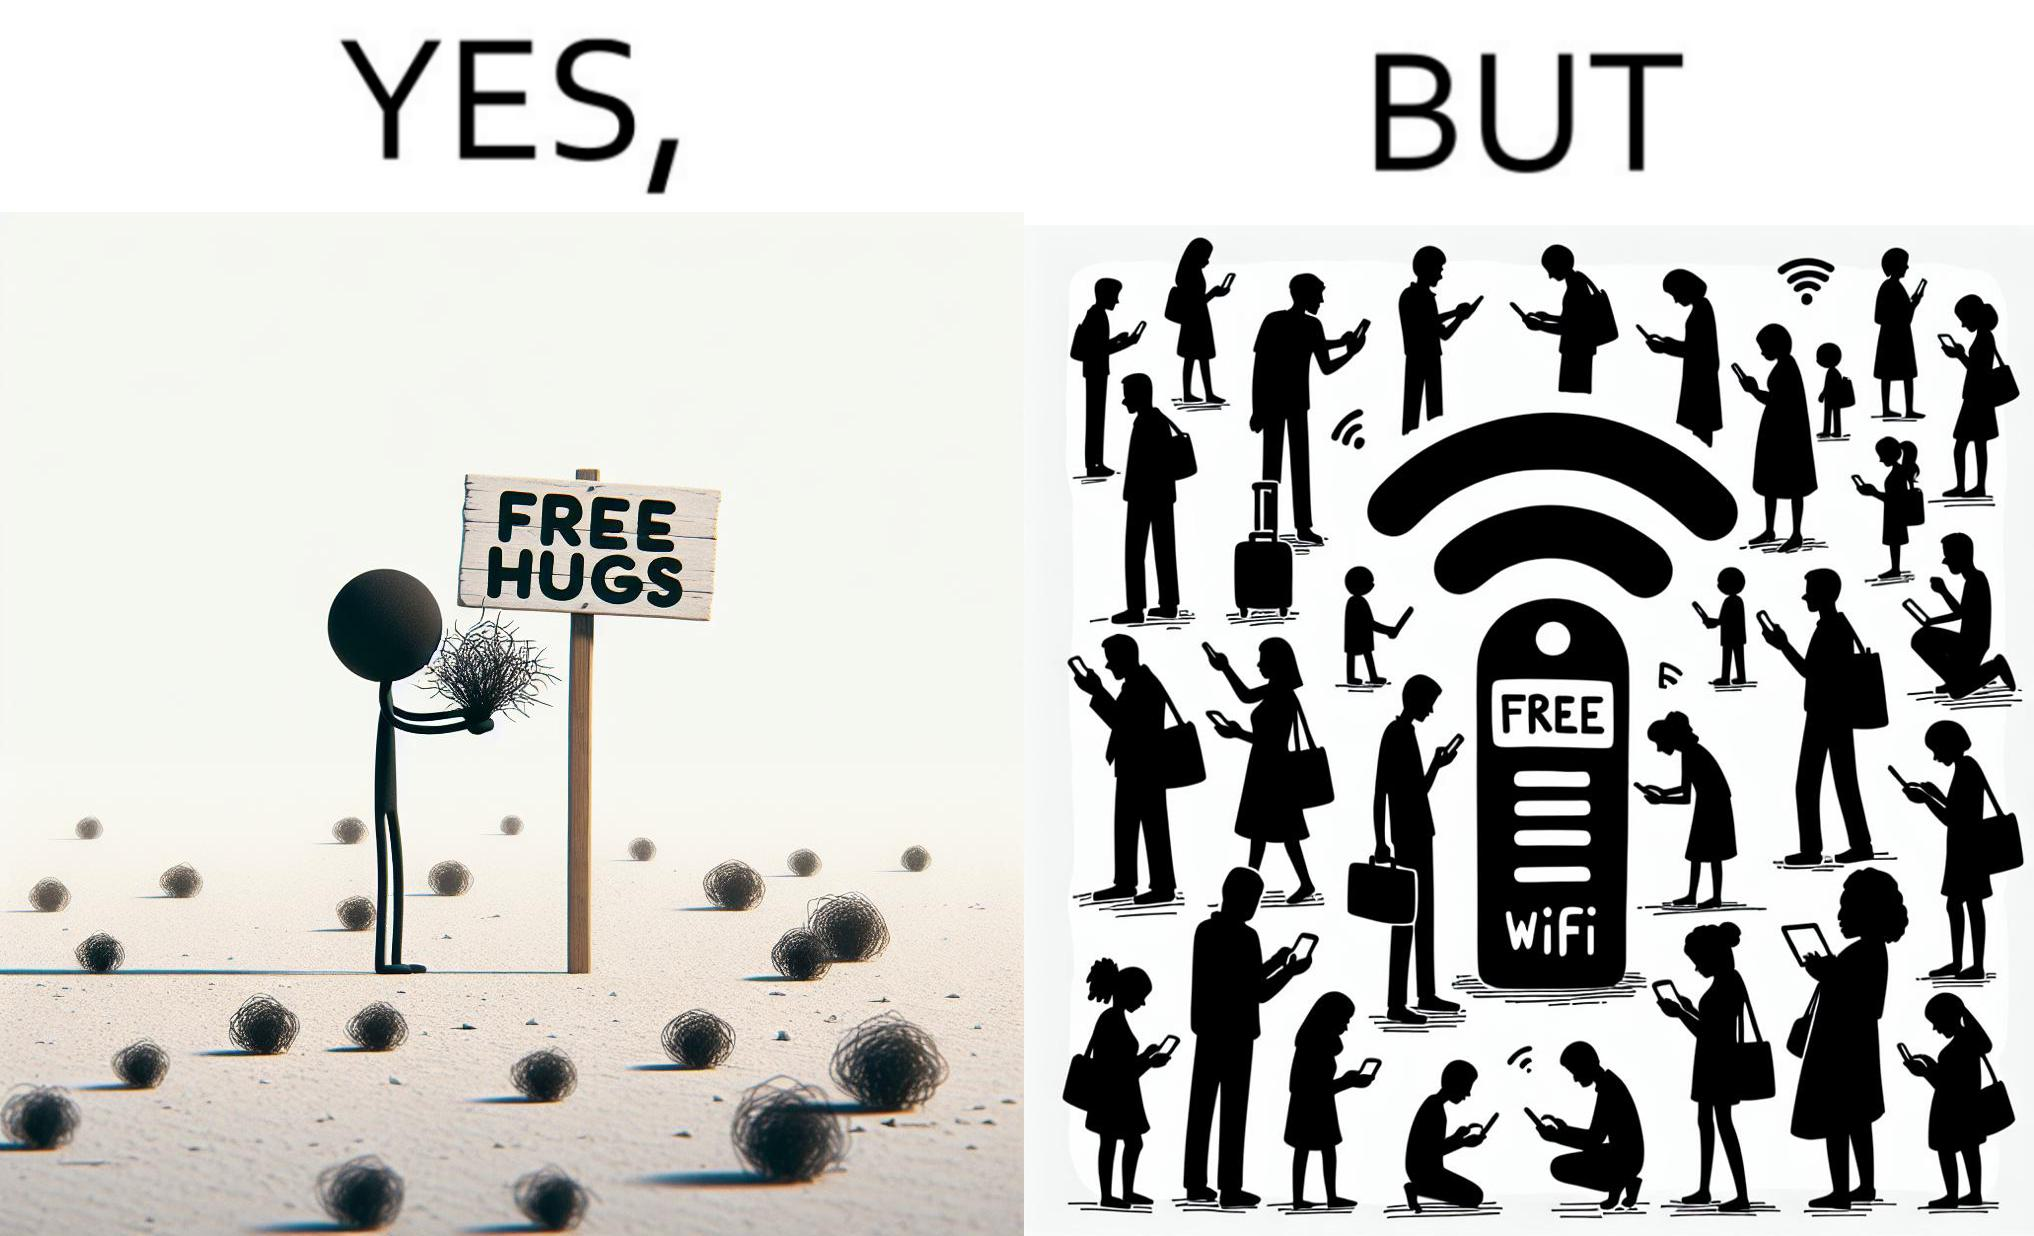What do you see in each half of this image? In the left part of the image: a person standing alone holding a sign "Free Hugs". The tumbleweeds blowing in the wind further stress on the loneliness. In the right part of the image: A Wi-fi Router with the label "Free Wifi" in front of it, surrounded by people trying to connect to it on their mobile devices. 